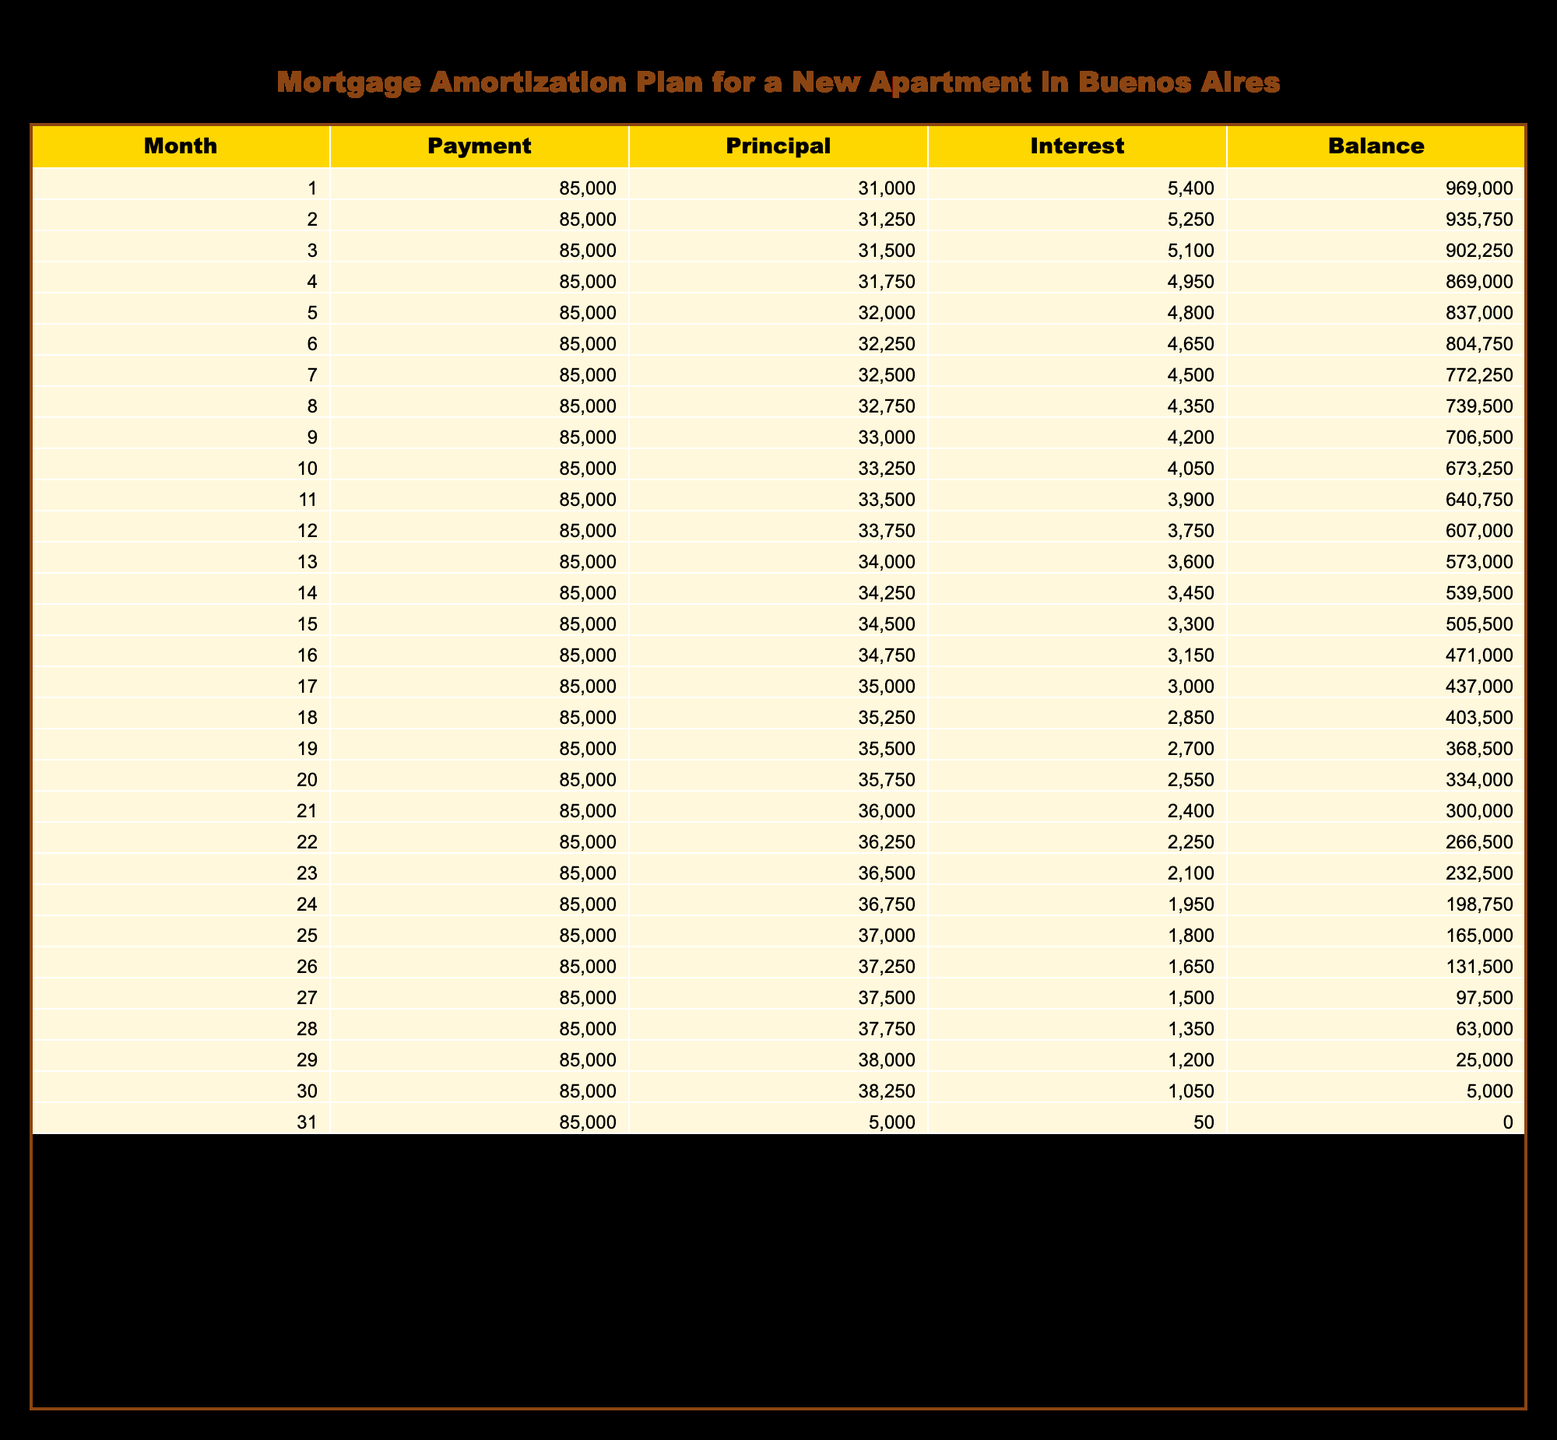What is the total payment made in the first three months? The total payment in the first three months can be calculated by adding the payments for each month: 85000 + 85000 + 85000 = 255000.
Answer: 255000 In which month is the principal payment the highest? The principal payment for each month is listed in the table, and the highest principal payment of 38250 occurs in the 30th month.
Answer: 30th month What is the initial balance at the start of the loan? The initial balance at the start of the loan is shown in the first row of the table, which is 1000000.
Answer: 1000000 Does the interest payment decrease over the entire loan period? Reviewing the interest payments from the table reveals that they start at 5400 and decrease monthly, reaching as low as 50 in the last month, confirming a consistent decrease.
Answer: Yes What is the total principal paid after 12 months? To find the total principal paid after 12 months, sum the principal payments for the first twelve months: 31000 + 31250 + 31500 + 31750 + 32000 + 32250 + 32500 + 32750 + 33000 + 33250 + 33500 + 33750 = 390000.
Answer: 390000 How much is left in the balance after 18 months? The balance after 18 months can be found in the 18th row of the table, which states the remaining balance is 403500.
Answer: 403500 What is the average principal payment made in the first 24 months? First, find the total principal paid in the first 24 months by summing the relevant amounts (31000 to 36750) = 390000 + 450000 = 3120000, then divide by 24 months: 3120000 / 24 = 130000.
Answer: 130000 In how many months does the total payment exceed the total interest paid? By adding the total payments and interest paid through the table, we see they exceed at the 26th month when total payments of 2210000 exceed interest of 1245000, indicating it takes 26 months to exceed total interest.
Answer: 26 months What is the balance reduction from the start to the 30th month? The starting balance is 1000000, and the balance after 30 months is 5000. The reduction is calculated by subtracting the final balance from the starting balance: 1000000 - 5000 = 995000.
Answer: 995000 